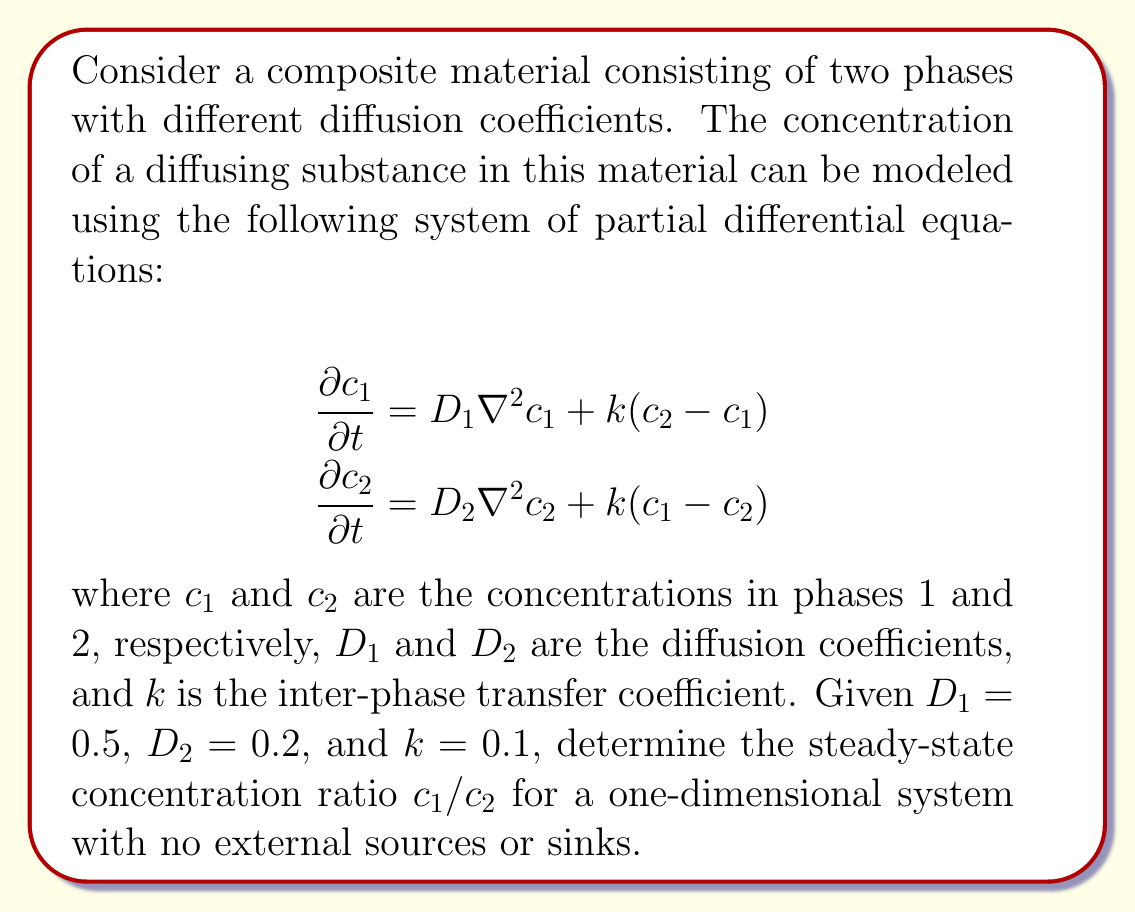Can you answer this question? To solve this problem, we'll follow these steps:

1) At steady state, the time derivatives become zero:

   $$\begin{align}
   0 &= D_1 \frac{\partial^2 c_1}{\partial x^2} + k(c_2 - c_1) \\
   0 &= D_2 \frac{\partial^2 c_2}{\partial x^2} + k(c_1 - c_2)
   \end{align}$$

2) In a one-dimensional system with no external sources or sinks, the spatial second derivatives will also be zero at steady state:

   $$\begin{align}
   0 &= k(c_2 - c_1) \\
   0 &= k(c_1 - c_2)
   \end{align}$$

3) These equations are equivalent and imply:

   $$c_1 = c_2$$

4) Therefore, at steady state, the concentration ratio is:

   $$\frac{c_1}{c_2} = 1$$

5) This result is independent of the values of $D_1$, $D_2$, and $k$, as long as $k \neq 0$.

This analysis shows that in a composite material with two phases and no external influences, the diffusing substance will eventually reach an equilibrium where its concentration is equal in both phases, regardless of their different diffusion coefficients.
Answer: $\frac{c_1}{c_2} = 1$ 